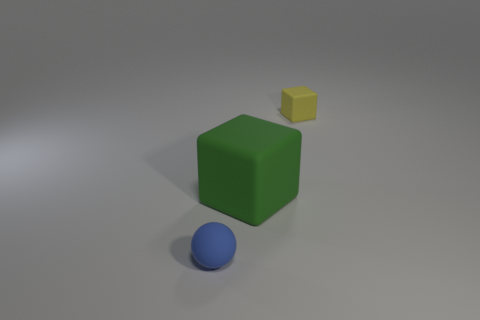Add 2 tiny blue rubber objects. How many objects exist? 5 Subtract 1 blocks. How many blocks are left? 1 Subtract all green blocks. How many blocks are left? 1 Subtract all blocks. How many objects are left? 1 Add 3 yellow matte blocks. How many yellow matte blocks are left? 4 Add 1 cubes. How many cubes exist? 3 Subtract 0 brown balls. How many objects are left? 3 Subtract all blue cubes. Subtract all red spheres. How many cubes are left? 2 Subtract all big purple metal spheres. Subtract all tiny rubber balls. How many objects are left? 2 